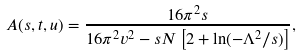Convert formula to latex. <formula><loc_0><loc_0><loc_500><loc_500>A ( s , t , u ) = \frac { 1 6 \pi ^ { 2 } s } { 1 6 \pi ^ { 2 } v ^ { 2 } - s N \left [ 2 + \ln ( - \Lambda ^ { 2 } / s ) \right ] } ,</formula> 